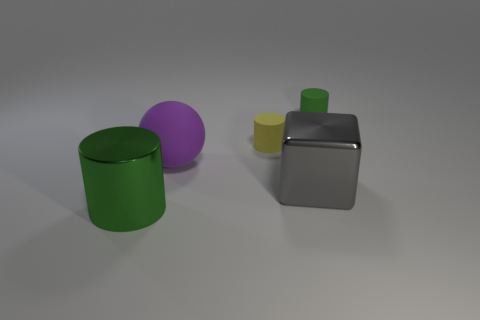Can you describe the colors of the objects shown in the image? Certainly, the image depicts four objects, each with its distinct color. Moving from left to right, there's a green cylinder, a purple sphere, a yellow smaller cylinder, and a gray cube. 